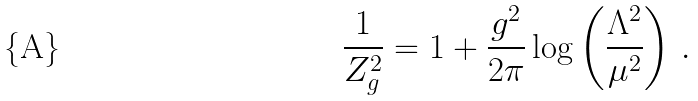Convert formula to latex. <formula><loc_0><loc_0><loc_500><loc_500>\frac { 1 } { Z _ { g } ^ { 2 } } = 1 + \frac { g ^ { 2 } } { 2 \pi } \log \left ( \frac { \Lambda ^ { 2 } } { \mu ^ { 2 } } \right ) \, .</formula> 